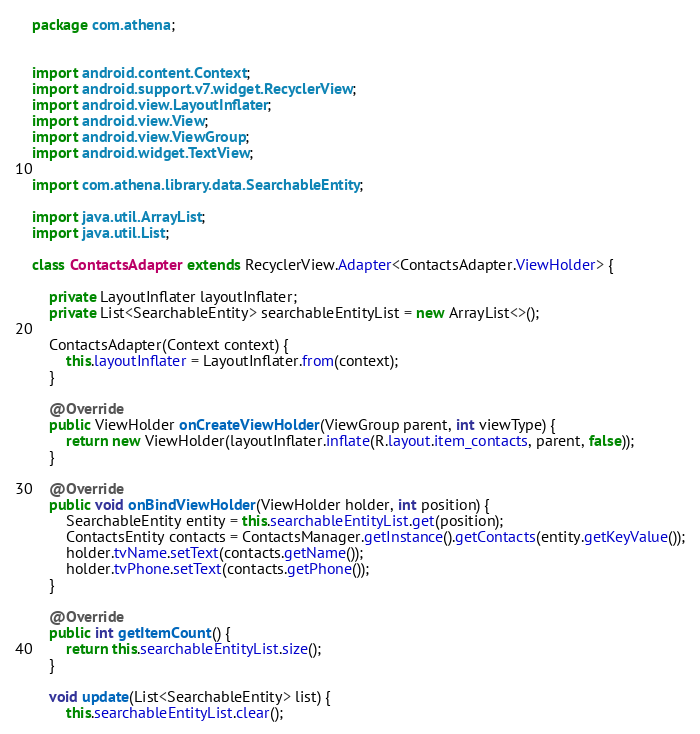Convert code to text. <code><loc_0><loc_0><loc_500><loc_500><_Java_>package com.athena;


import android.content.Context;
import android.support.v7.widget.RecyclerView;
import android.view.LayoutInflater;
import android.view.View;
import android.view.ViewGroup;
import android.widget.TextView;

import com.athena.library.data.SearchableEntity;

import java.util.ArrayList;
import java.util.List;

class ContactsAdapter extends RecyclerView.Adapter<ContactsAdapter.ViewHolder> {

    private LayoutInflater layoutInflater;
    private List<SearchableEntity> searchableEntityList = new ArrayList<>();

    ContactsAdapter(Context context) {
        this.layoutInflater = LayoutInflater.from(context);
    }

    @Override
    public ViewHolder onCreateViewHolder(ViewGroup parent, int viewType) {
        return new ViewHolder(layoutInflater.inflate(R.layout.item_contacts, parent, false));
    }

    @Override
    public void onBindViewHolder(ViewHolder holder, int position) {
        SearchableEntity entity = this.searchableEntityList.get(position);
        ContactsEntity contacts = ContactsManager.getInstance().getContacts(entity.getKeyValue());
        holder.tvName.setText(contacts.getName());
        holder.tvPhone.setText(contacts.getPhone());
    }

    @Override
    public int getItemCount() {
        return this.searchableEntityList.size();
    }

    void update(List<SearchableEntity> list) {
        this.searchableEntityList.clear();</code> 